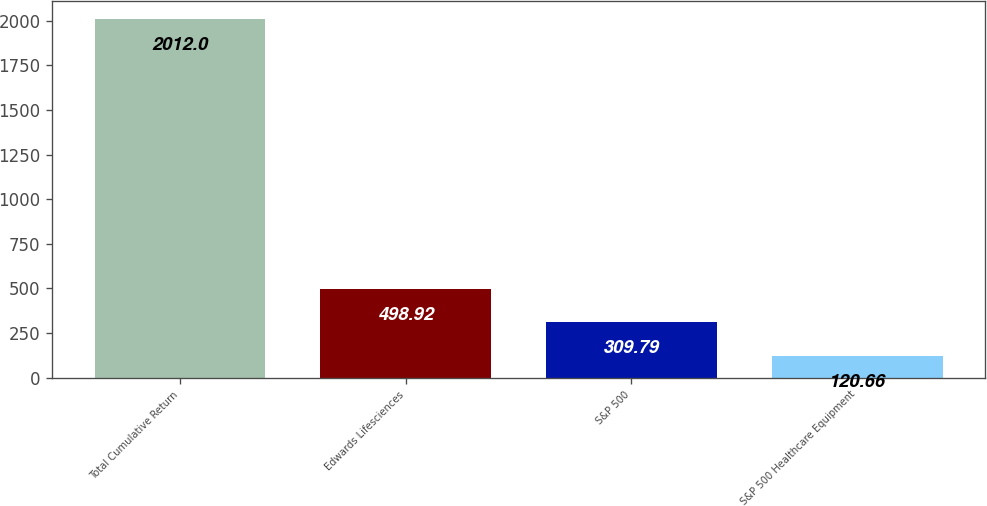Convert chart. <chart><loc_0><loc_0><loc_500><loc_500><bar_chart><fcel>Total Cumulative Return<fcel>Edwards Lifesciences<fcel>S&P 500<fcel>S&P 500 Healthcare Equipment<nl><fcel>2012<fcel>498.92<fcel>309.79<fcel>120.66<nl></chart> 